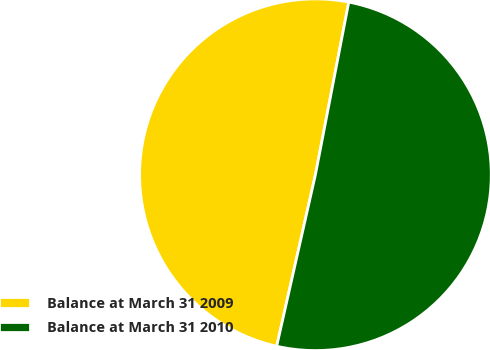Convert chart. <chart><loc_0><loc_0><loc_500><loc_500><pie_chart><fcel>Balance at March 31 2009<fcel>Balance at March 31 2010<nl><fcel>49.5%<fcel>50.5%<nl></chart> 